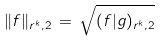Convert formula to latex. <formula><loc_0><loc_0><loc_500><loc_500>\| f \| _ { r ^ { k } , 2 } \, = \, \sqrt { ( f | g ) _ { r ^ { k } , 2 } }</formula> 